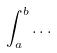Convert formula to latex. <formula><loc_0><loc_0><loc_500><loc_500>\int _ { a } ^ { b } \dots</formula> 